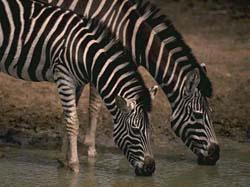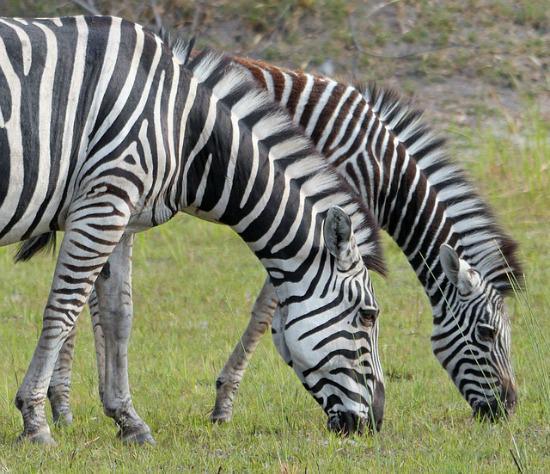The first image is the image on the left, the second image is the image on the right. Considering the images on both sides, is "The combined images include at least four zebras standing in profile with heads and necks curved to the ground." valid? Answer yes or no. Yes. The first image is the image on the left, the second image is the image on the right. Given the left and right images, does the statement "The left and right image contains the same number of zebras." hold true? Answer yes or no. Yes. 